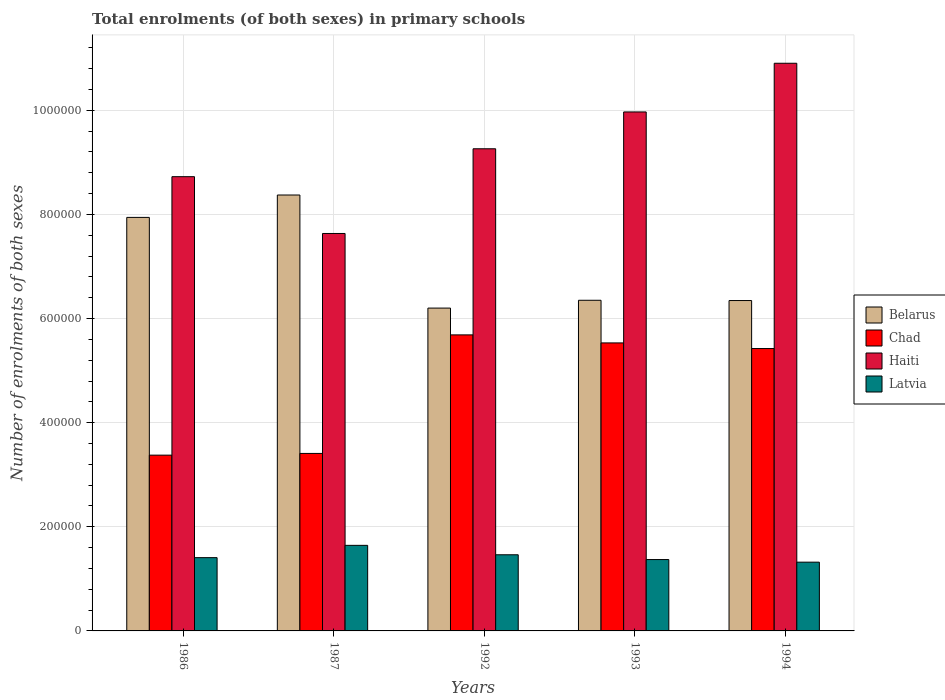How many different coloured bars are there?
Your answer should be compact. 4. Are the number of bars per tick equal to the number of legend labels?
Offer a terse response. Yes. Are the number of bars on each tick of the X-axis equal?
Keep it short and to the point. Yes. How many bars are there on the 4th tick from the left?
Keep it short and to the point. 4. What is the label of the 1st group of bars from the left?
Offer a very short reply. 1986. In how many cases, is the number of bars for a given year not equal to the number of legend labels?
Ensure brevity in your answer.  0. What is the number of enrolments in primary schools in Haiti in 1993?
Offer a terse response. 9.97e+05. Across all years, what is the maximum number of enrolments in primary schools in Latvia?
Provide a short and direct response. 1.64e+05. Across all years, what is the minimum number of enrolments in primary schools in Chad?
Provide a short and direct response. 3.38e+05. In which year was the number of enrolments in primary schools in Chad maximum?
Provide a short and direct response. 1992. In which year was the number of enrolments in primary schools in Latvia minimum?
Provide a short and direct response. 1994. What is the total number of enrolments in primary schools in Belarus in the graph?
Offer a very short reply. 3.52e+06. What is the difference between the number of enrolments in primary schools in Chad in 1992 and that in 1994?
Your answer should be very brief. 2.62e+04. What is the difference between the number of enrolments in primary schools in Haiti in 1993 and the number of enrolments in primary schools in Belarus in 1987?
Your response must be concise. 1.60e+05. What is the average number of enrolments in primary schools in Chad per year?
Keep it short and to the point. 4.69e+05. In the year 1987, what is the difference between the number of enrolments in primary schools in Latvia and number of enrolments in primary schools in Haiti?
Your answer should be very brief. -5.99e+05. In how many years, is the number of enrolments in primary schools in Belarus greater than 240000?
Keep it short and to the point. 5. What is the ratio of the number of enrolments in primary schools in Chad in 1986 to that in 1994?
Make the answer very short. 0.62. Is the difference between the number of enrolments in primary schools in Latvia in 1993 and 1994 greater than the difference between the number of enrolments in primary schools in Haiti in 1993 and 1994?
Keep it short and to the point. Yes. What is the difference between the highest and the second highest number of enrolments in primary schools in Chad?
Keep it short and to the point. 1.54e+04. What is the difference between the highest and the lowest number of enrolments in primary schools in Chad?
Make the answer very short. 2.31e+05. In how many years, is the number of enrolments in primary schools in Haiti greater than the average number of enrolments in primary schools in Haiti taken over all years?
Offer a very short reply. 2. Is the sum of the number of enrolments in primary schools in Chad in 1993 and 1994 greater than the maximum number of enrolments in primary schools in Haiti across all years?
Ensure brevity in your answer.  Yes. What does the 4th bar from the left in 1986 represents?
Your response must be concise. Latvia. What does the 2nd bar from the right in 1992 represents?
Keep it short and to the point. Haiti. Is it the case that in every year, the sum of the number of enrolments in primary schools in Chad and number of enrolments in primary schools in Latvia is greater than the number of enrolments in primary schools in Belarus?
Make the answer very short. No. Are all the bars in the graph horizontal?
Give a very brief answer. No. How many years are there in the graph?
Provide a short and direct response. 5. Are the values on the major ticks of Y-axis written in scientific E-notation?
Provide a succinct answer. No. Does the graph contain any zero values?
Provide a succinct answer. No. Does the graph contain grids?
Your response must be concise. Yes. How are the legend labels stacked?
Provide a succinct answer. Vertical. What is the title of the graph?
Offer a terse response. Total enrolments (of both sexes) in primary schools. Does "Jamaica" appear as one of the legend labels in the graph?
Offer a very short reply. No. What is the label or title of the X-axis?
Offer a terse response. Years. What is the label or title of the Y-axis?
Provide a succinct answer. Number of enrolments of both sexes. What is the Number of enrolments of both sexes of Belarus in 1986?
Make the answer very short. 7.94e+05. What is the Number of enrolments of both sexes in Chad in 1986?
Offer a terse response. 3.38e+05. What is the Number of enrolments of both sexes in Haiti in 1986?
Offer a terse response. 8.72e+05. What is the Number of enrolments of both sexes of Latvia in 1986?
Provide a short and direct response. 1.41e+05. What is the Number of enrolments of both sexes in Belarus in 1987?
Provide a short and direct response. 8.37e+05. What is the Number of enrolments of both sexes in Chad in 1987?
Your response must be concise. 3.41e+05. What is the Number of enrolments of both sexes in Haiti in 1987?
Give a very brief answer. 7.63e+05. What is the Number of enrolments of both sexes in Latvia in 1987?
Your answer should be compact. 1.64e+05. What is the Number of enrolments of both sexes of Belarus in 1992?
Offer a very short reply. 6.20e+05. What is the Number of enrolments of both sexes in Chad in 1992?
Offer a very short reply. 5.69e+05. What is the Number of enrolments of both sexes in Haiti in 1992?
Keep it short and to the point. 9.26e+05. What is the Number of enrolments of both sexes of Latvia in 1992?
Provide a succinct answer. 1.46e+05. What is the Number of enrolments of both sexes of Belarus in 1993?
Your answer should be compact. 6.35e+05. What is the Number of enrolments of both sexes in Chad in 1993?
Ensure brevity in your answer.  5.53e+05. What is the Number of enrolments of both sexes of Haiti in 1993?
Provide a succinct answer. 9.97e+05. What is the Number of enrolments of both sexes in Latvia in 1993?
Keep it short and to the point. 1.37e+05. What is the Number of enrolments of both sexes in Belarus in 1994?
Provide a succinct answer. 6.35e+05. What is the Number of enrolments of both sexes of Chad in 1994?
Your answer should be very brief. 5.42e+05. What is the Number of enrolments of both sexes in Haiti in 1994?
Give a very brief answer. 1.09e+06. What is the Number of enrolments of both sexes of Latvia in 1994?
Your answer should be very brief. 1.32e+05. Across all years, what is the maximum Number of enrolments of both sexes in Belarus?
Keep it short and to the point. 8.37e+05. Across all years, what is the maximum Number of enrolments of both sexes in Chad?
Provide a short and direct response. 5.69e+05. Across all years, what is the maximum Number of enrolments of both sexes of Haiti?
Make the answer very short. 1.09e+06. Across all years, what is the maximum Number of enrolments of both sexes of Latvia?
Ensure brevity in your answer.  1.64e+05. Across all years, what is the minimum Number of enrolments of both sexes of Belarus?
Ensure brevity in your answer.  6.20e+05. Across all years, what is the minimum Number of enrolments of both sexes of Chad?
Offer a very short reply. 3.38e+05. Across all years, what is the minimum Number of enrolments of both sexes of Haiti?
Your answer should be compact. 7.63e+05. Across all years, what is the minimum Number of enrolments of both sexes in Latvia?
Your response must be concise. 1.32e+05. What is the total Number of enrolments of both sexes of Belarus in the graph?
Your answer should be compact. 3.52e+06. What is the total Number of enrolments of both sexes of Chad in the graph?
Keep it short and to the point. 2.34e+06. What is the total Number of enrolments of both sexes of Haiti in the graph?
Provide a short and direct response. 4.65e+06. What is the total Number of enrolments of both sexes of Latvia in the graph?
Your answer should be compact. 7.21e+05. What is the difference between the Number of enrolments of both sexes in Belarus in 1986 and that in 1987?
Your response must be concise. -4.30e+04. What is the difference between the Number of enrolments of both sexes in Chad in 1986 and that in 1987?
Keep it short and to the point. -3304. What is the difference between the Number of enrolments of both sexes in Haiti in 1986 and that in 1987?
Give a very brief answer. 1.09e+05. What is the difference between the Number of enrolments of both sexes in Latvia in 1986 and that in 1987?
Make the answer very short. -2.36e+04. What is the difference between the Number of enrolments of both sexes of Belarus in 1986 and that in 1992?
Offer a terse response. 1.74e+05. What is the difference between the Number of enrolments of both sexes of Chad in 1986 and that in 1992?
Make the answer very short. -2.31e+05. What is the difference between the Number of enrolments of both sexes of Haiti in 1986 and that in 1992?
Offer a terse response. -5.36e+04. What is the difference between the Number of enrolments of both sexes in Latvia in 1986 and that in 1992?
Offer a terse response. -5506. What is the difference between the Number of enrolments of both sexes in Belarus in 1986 and that in 1993?
Your answer should be very brief. 1.59e+05. What is the difference between the Number of enrolments of both sexes of Chad in 1986 and that in 1993?
Provide a short and direct response. -2.16e+05. What is the difference between the Number of enrolments of both sexes in Haiti in 1986 and that in 1993?
Your answer should be very brief. -1.24e+05. What is the difference between the Number of enrolments of both sexes of Latvia in 1986 and that in 1993?
Offer a terse response. 3649. What is the difference between the Number of enrolments of both sexes of Belarus in 1986 and that in 1994?
Ensure brevity in your answer.  1.60e+05. What is the difference between the Number of enrolments of both sexes in Chad in 1986 and that in 1994?
Keep it short and to the point. -2.05e+05. What is the difference between the Number of enrolments of both sexes in Haiti in 1986 and that in 1994?
Make the answer very short. -2.18e+05. What is the difference between the Number of enrolments of both sexes of Latvia in 1986 and that in 1994?
Your answer should be compact. 8685. What is the difference between the Number of enrolments of both sexes of Belarus in 1987 and that in 1992?
Your response must be concise. 2.17e+05. What is the difference between the Number of enrolments of both sexes of Chad in 1987 and that in 1992?
Your response must be concise. -2.28e+05. What is the difference between the Number of enrolments of both sexes in Haiti in 1987 and that in 1992?
Your response must be concise. -1.63e+05. What is the difference between the Number of enrolments of both sexes of Latvia in 1987 and that in 1992?
Provide a succinct answer. 1.81e+04. What is the difference between the Number of enrolments of both sexes in Belarus in 1987 and that in 1993?
Your answer should be compact. 2.02e+05. What is the difference between the Number of enrolments of both sexes in Chad in 1987 and that in 1993?
Keep it short and to the point. -2.12e+05. What is the difference between the Number of enrolments of both sexes in Haiti in 1987 and that in 1993?
Your answer should be very brief. -2.33e+05. What is the difference between the Number of enrolments of both sexes in Latvia in 1987 and that in 1993?
Your response must be concise. 2.73e+04. What is the difference between the Number of enrolments of both sexes of Belarus in 1987 and that in 1994?
Make the answer very short. 2.03e+05. What is the difference between the Number of enrolments of both sexes in Chad in 1987 and that in 1994?
Your response must be concise. -2.01e+05. What is the difference between the Number of enrolments of both sexes in Haiti in 1987 and that in 1994?
Provide a succinct answer. -3.27e+05. What is the difference between the Number of enrolments of both sexes of Latvia in 1987 and that in 1994?
Offer a terse response. 3.23e+04. What is the difference between the Number of enrolments of both sexes in Belarus in 1992 and that in 1993?
Provide a short and direct response. -1.50e+04. What is the difference between the Number of enrolments of both sexes in Chad in 1992 and that in 1993?
Give a very brief answer. 1.54e+04. What is the difference between the Number of enrolments of both sexes in Haiti in 1992 and that in 1993?
Your answer should be compact. -7.08e+04. What is the difference between the Number of enrolments of both sexes of Latvia in 1992 and that in 1993?
Make the answer very short. 9155. What is the difference between the Number of enrolments of both sexes of Belarus in 1992 and that in 1994?
Your response must be concise. -1.45e+04. What is the difference between the Number of enrolments of both sexes of Chad in 1992 and that in 1994?
Offer a very short reply. 2.62e+04. What is the difference between the Number of enrolments of both sexes in Haiti in 1992 and that in 1994?
Your answer should be very brief. -1.64e+05. What is the difference between the Number of enrolments of both sexes in Latvia in 1992 and that in 1994?
Offer a very short reply. 1.42e+04. What is the difference between the Number of enrolments of both sexes of Belarus in 1993 and that in 1994?
Offer a very short reply. 500. What is the difference between the Number of enrolments of both sexes of Chad in 1993 and that in 1994?
Your answer should be compact. 1.08e+04. What is the difference between the Number of enrolments of both sexes of Haiti in 1993 and that in 1994?
Offer a very short reply. -9.35e+04. What is the difference between the Number of enrolments of both sexes of Latvia in 1993 and that in 1994?
Your answer should be compact. 5036. What is the difference between the Number of enrolments of both sexes of Belarus in 1986 and the Number of enrolments of both sexes of Chad in 1987?
Give a very brief answer. 4.53e+05. What is the difference between the Number of enrolments of both sexes in Belarus in 1986 and the Number of enrolments of both sexes in Haiti in 1987?
Provide a short and direct response. 3.09e+04. What is the difference between the Number of enrolments of both sexes in Belarus in 1986 and the Number of enrolments of both sexes in Latvia in 1987?
Offer a terse response. 6.30e+05. What is the difference between the Number of enrolments of both sexes of Chad in 1986 and the Number of enrolments of both sexes of Haiti in 1987?
Make the answer very short. -4.26e+05. What is the difference between the Number of enrolments of both sexes in Chad in 1986 and the Number of enrolments of both sexes in Latvia in 1987?
Make the answer very short. 1.73e+05. What is the difference between the Number of enrolments of both sexes in Haiti in 1986 and the Number of enrolments of both sexes in Latvia in 1987?
Make the answer very short. 7.08e+05. What is the difference between the Number of enrolments of both sexes of Belarus in 1986 and the Number of enrolments of both sexes of Chad in 1992?
Your response must be concise. 2.26e+05. What is the difference between the Number of enrolments of both sexes of Belarus in 1986 and the Number of enrolments of both sexes of Haiti in 1992?
Provide a succinct answer. -1.32e+05. What is the difference between the Number of enrolments of both sexes in Belarus in 1986 and the Number of enrolments of both sexes in Latvia in 1992?
Provide a short and direct response. 6.48e+05. What is the difference between the Number of enrolments of both sexes of Chad in 1986 and the Number of enrolments of both sexes of Haiti in 1992?
Make the answer very short. -5.88e+05. What is the difference between the Number of enrolments of both sexes of Chad in 1986 and the Number of enrolments of both sexes of Latvia in 1992?
Keep it short and to the point. 1.91e+05. What is the difference between the Number of enrolments of both sexes of Haiti in 1986 and the Number of enrolments of both sexes of Latvia in 1992?
Keep it short and to the point. 7.26e+05. What is the difference between the Number of enrolments of both sexes of Belarus in 1986 and the Number of enrolments of both sexes of Chad in 1993?
Ensure brevity in your answer.  2.41e+05. What is the difference between the Number of enrolments of both sexes in Belarus in 1986 and the Number of enrolments of both sexes in Haiti in 1993?
Your response must be concise. -2.03e+05. What is the difference between the Number of enrolments of both sexes of Belarus in 1986 and the Number of enrolments of both sexes of Latvia in 1993?
Offer a very short reply. 6.57e+05. What is the difference between the Number of enrolments of both sexes in Chad in 1986 and the Number of enrolments of both sexes in Haiti in 1993?
Your answer should be very brief. -6.59e+05. What is the difference between the Number of enrolments of both sexes in Chad in 1986 and the Number of enrolments of both sexes in Latvia in 1993?
Provide a short and direct response. 2.01e+05. What is the difference between the Number of enrolments of both sexes of Haiti in 1986 and the Number of enrolments of both sexes of Latvia in 1993?
Provide a succinct answer. 7.35e+05. What is the difference between the Number of enrolments of both sexes of Belarus in 1986 and the Number of enrolments of both sexes of Chad in 1994?
Your response must be concise. 2.52e+05. What is the difference between the Number of enrolments of both sexes in Belarus in 1986 and the Number of enrolments of both sexes in Haiti in 1994?
Provide a short and direct response. -2.96e+05. What is the difference between the Number of enrolments of both sexes of Belarus in 1986 and the Number of enrolments of both sexes of Latvia in 1994?
Ensure brevity in your answer.  6.62e+05. What is the difference between the Number of enrolments of both sexes of Chad in 1986 and the Number of enrolments of both sexes of Haiti in 1994?
Make the answer very short. -7.53e+05. What is the difference between the Number of enrolments of both sexes of Chad in 1986 and the Number of enrolments of both sexes of Latvia in 1994?
Make the answer very short. 2.06e+05. What is the difference between the Number of enrolments of both sexes in Haiti in 1986 and the Number of enrolments of both sexes in Latvia in 1994?
Your answer should be very brief. 7.40e+05. What is the difference between the Number of enrolments of both sexes in Belarus in 1987 and the Number of enrolments of both sexes in Chad in 1992?
Make the answer very short. 2.69e+05. What is the difference between the Number of enrolments of both sexes in Belarus in 1987 and the Number of enrolments of both sexes in Haiti in 1992?
Provide a succinct answer. -8.88e+04. What is the difference between the Number of enrolments of both sexes in Belarus in 1987 and the Number of enrolments of both sexes in Latvia in 1992?
Your response must be concise. 6.91e+05. What is the difference between the Number of enrolments of both sexes in Chad in 1987 and the Number of enrolments of both sexes in Haiti in 1992?
Give a very brief answer. -5.85e+05. What is the difference between the Number of enrolments of both sexes of Chad in 1987 and the Number of enrolments of both sexes of Latvia in 1992?
Provide a short and direct response. 1.95e+05. What is the difference between the Number of enrolments of both sexes of Haiti in 1987 and the Number of enrolments of both sexes of Latvia in 1992?
Your answer should be very brief. 6.17e+05. What is the difference between the Number of enrolments of both sexes in Belarus in 1987 and the Number of enrolments of both sexes in Chad in 1993?
Provide a succinct answer. 2.84e+05. What is the difference between the Number of enrolments of both sexes in Belarus in 1987 and the Number of enrolments of both sexes in Haiti in 1993?
Provide a succinct answer. -1.60e+05. What is the difference between the Number of enrolments of both sexes of Belarus in 1987 and the Number of enrolments of both sexes of Latvia in 1993?
Ensure brevity in your answer.  7.00e+05. What is the difference between the Number of enrolments of both sexes of Chad in 1987 and the Number of enrolments of both sexes of Haiti in 1993?
Provide a short and direct response. -6.56e+05. What is the difference between the Number of enrolments of both sexes of Chad in 1987 and the Number of enrolments of both sexes of Latvia in 1993?
Make the answer very short. 2.04e+05. What is the difference between the Number of enrolments of both sexes of Haiti in 1987 and the Number of enrolments of both sexes of Latvia in 1993?
Ensure brevity in your answer.  6.26e+05. What is the difference between the Number of enrolments of both sexes in Belarus in 1987 and the Number of enrolments of both sexes in Chad in 1994?
Ensure brevity in your answer.  2.95e+05. What is the difference between the Number of enrolments of both sexes of Belarus in 1987 and the Number of enrolments of both sexes of Haiti in 1994?
Provide a short and direct response. -2.53e+05. What is the difference between the Number of enrolments of both sexes in Belarus in 1987 and the Number of enrolments of both sexes in Latvia in 1994?
Offer a very short reply. 7.05e+05. What is the difference between the Number of enrolments of both sexes of Chad in 1987 and the Number of enrolments of both sexes of Haiti in 1994?
Provide a succinct answer. -7.49e+05. What is the difference between the Number of enrolments of both sexes in Chad in 1987 and the Number of enrolments of both sexes in Latvia in 1994?
Offer a very short reply. 2.09e+05. What is the difference between the Number of enrolments of both sexes in Haiti in 1987 and the Number of enrolments of both sexes in Latvia in 1994?
Your answer should be compact. 6.31e+05. What is the difference between the Number of enrolments of both sexes of Belarus in 1992 and the Number of enrolments of both sexes of Chad in 1993?
Provide a succinct answer. 6.69e+04. What is the difference between the Number of enrolments of both sexes in Belarus in 1992 and the Number of enrolments of both sexes in Haiti in 1993?
Offer a very short reply. -3.77e+05. What is the difference between the Number of enrolments of both sexes of Belarus in 1992 and the Number of enrolments of both sexes of Latvia in 1993?
Offer a terse response. 4.83e+05. What is the difference between the Number of enrolments of both sexes in Chad in 1992 and the Number of enrolments of both sexes in Haiti in 1993?
Your response must be concise. -4.28e+05. What is the difference between the Number of enrolments of both sexes in Chad in 1992 and the Number of enrolments of both sexes in Latvia in 1993?
Provide a succinct answer. 4.32e+05. What is the difference between the Number of enrolments of both sexes in Haiti in 1992 and the Number of enrolments of both sexes in Latvia in 1993?
Offer a terse response. 7.89e+05. What is the difference between the Number of enrolments of both sexes in Belarus in 1992 and the Number of enrolments of both sexes in Chad in 1994?
Provide a short and direct response. 7.77e+04. What is the difference between the Number of enrolments of both sexes in Belarus in 1992 and the Number of enrolments of both sexes in Haiti in 1994?
Your answer should be compact. -4.70e+05. What is the difference between the Number of enrolments of both sexes in Belarus in 1992 and the Number of enrolments of both sexes in Latvia in 1994?
Offer a very short reply. 4.88e+05. What is the difference between the Number of enrolments of both sexes in Chad in 1992 and the Number of enrolments of both sexes in Haiti in 1994?
Provide a succinct answer. -5.22e+05. What is the difference between the Number of enrolments of both sexes of Chad in 1992 and the Number of enrolments of both sexes of Latvia in 1994?
Your response must be concise. 4.37e+05. What is the difference between the Number of enrolments of both sexes in Haiti in 1992 and the Number of enrolments of both sexes in Latvia in 1994?
Offer a very short reply. 7.94e+05. What is the difference between the Number of enrolments of both sexes in Belarus in 1993 and the Number of enrolments of both sexes in Chad in 1994?
Offer a very short reply. 9.27e+04. What is the difference between the Number of enrolments of both sexes in Belarus in 1993 and the Number of enrolments of both sexes in Haiti in 1994?
Your answer should be very brief. -4.55e+05. What is the difference between the Number of enrolments of both sexes of Belarus in 1993 and the Number of enrolments of both sexes of Latvia in 1994?
Provide a short and direct response. 5.03e+05. What is the difference between the Number of enrolments of both sexes of Chad in 1993 and the Number of enrolments of both sexes of Haiti in 1994?
Make the answer very short. -5.37e+05. What is the difference between the Number of enrolments of both sexes of Chad in 1993 and the Number of enrolments of both sexes of Latvia in 1994?
Give a very brief answer. 4.21e+05. What is the difference between the Number of enrolments of both sexes in Haiti in 1993 and the Number of enrolments of both sexes in Latvia in 1994?
Your answer should be compact. 8.65e+05. What is the average Number of enrolments of both sexes of Belarus per year?
Keep it short and to the point. 7.04e+05. What is the average Number of enrolments of both sexes in Chad per year?
Your response must be concise. 4.69e+05. What is the average Number of enrolments of both sexes in Haiti per year?
Offer a terse response. 9.30e+05. What is the average Number of enrolments of both sexes of Latvia per year?
Your answer should be very brief. 1.44e+05. In the year 1986, what is the difference between the Number of enrolments of both sexes of Belarus and Number of enrolments of both sexes of Chad?
Make the answer very short. 4.57e+05. In the year 1986, what is the difference between the Number of enrolments of both sexes in Belarus and Number of enrolments of both sexes in Haiti?
Give a very brief answer. -7.82e+04. In the year 1986, what is the difference between the Number of enrolments of both sexes of Belarus and Number of enrolments of both sexes of Latvia?
Ensure brevity in your answer.  6.54e+05. In the year 1986, what is the difference between the Number of enrolments of both sexes of Chad and Number of enrolments of both sexes of Haiti?
Provide a short and direct response. -5.35e+05. In the year 1986, what is the difference between the Number of enrolments of both sexes of Chad and Number of enrolments of both sexes of Latvia?
Offer a terse response. 1.97e+05. In the year 1986, what is the difference between the Number of enrolments of both sexes of Haiti and Number of enrolments of both sexes of Latvia?
Provide a succinct answer. 7.32e+05. In the year 1987, what is the difference between the Number of enrolments of both sexes in Belarus and Number of enrolments of both sexes in Chad?
Your response must be concise. 4.96e+05. In the year 1987, what is the difference between the Number of enrolments of both sexes in Belarus and Number of enrolments of both sexes in Haiti?
Your response must be concise. 7.39e+04. In the year 1987, what is the difference between the Number of enrolments of both sexes of Belarus and Number of enrolments of both sexes of Latvia?
Your answer should be very brief. 6.73e+05. In the year 1987, what is the difference between the Number of enrolments of both sexes in Chad and Number of enrolments of both sexes in Haiti?
Offer a terse response. -4.22e+05. In the year 1987, what is the difference between the Number of enrolments of both sexes of Chad and Number of enrolments of both sexes of Latvia?
Your answer should be compact. 1.77e+05. In the year 1987, what is the difference between the Number of enrolments of both sexes in Haiti and Number of enrolments of both sexes in Latvia?
Your answer should be very brief. 5.99e+05. In the year 1992, what is the difference between the Number of enrolments of both sexes in Belarus and Number of enrolments of both sexes in Chad?
Your response must be concise. 5.15e+04. In the year 1992, what is the difference between the Number of enrolments of both sexes of Belarus and Number of enrolments of both sexes of Haiti?
Offer a terse response. -3.06e+05. In the year 1992, what is the difference between the Number of enrolments of both sexes of Belarus and Number of enrolments of both sexes of Latvia?
Make the answer very short. 4.74e+05. In the year 1992, what is the difference between the Number of enrolments of both sexes in Chad and Number of enrolments of both sexes in Haiti?
Your answer should be compact. -3.57e+05. In the year 1992, what is the difference between the Number of enrolments of both sexes of Chad and Number of enrolments of both sexes of Latvia?
Your answer should be very brief. 4.22e+05. In the year 1992, what is the difference between the Number of enrolments of both sexes in Haiti and Number of enrolments of both sexes in Latvia?
Your answer should be very brief. 7.80e+05. In the year 1993, what is the difference between the Number of enrolments of both sexes of Belarus and Number of enrolments of both sexes of Chad?
Make the answer very short. 8.19e+04. In the year 1993, what is the difference between the Number of enrolments of both sexes of Belarus and Number of enrolments of both sexes of Haiti?
Offer a very short reply. -3.62e+05. In the year 1993, what is the difference between the Number of enrolments of both sexes in Belarus and Number of enrolments of both sexes in Latvia?
Keep it short and to the point. 4.98e+05. In the year 1993, what is the difference between the Number of enrolments of both sexes of Chad and Number of enrolments of both sexes of Haiti?
Provide a succinct answer. -4.44e+05. In the year 1993, what is the difference between the Number of enrolments of both sexes of Chad and Number of enrolments of both sexes of Latvia?
Provide a short and direct response. 4.16e+05. In the year 1993, what is the difference between the Number of enrolments of both sexes in Haiti and Number of enrolments of both sexes in Latvia?
Provide a short and direct response. 8.60e+05. In the year 1994, what is the difference between the Number of enrolments of both sexes in Belarus and Number of enrolments of both sexes in Chad?
Offer a terse response. 9.22e+04. In the year 1994, what is the difference between the Number of enrolments of both sexes of Belarus and Number of enrolments of both sexes of Haiti?
Your response must be concise. -4.56e+05. In the year 1994, what is the difference between the Number of enrolments of both sexes in Belarus and Number of enrolments of both sexes in Latvia?
Offer a terse response. 5.03e+05. In the year 1994, what is the difference between the Number of enrolments of both sexes of Chad and Number of enrolments of both sexes of Haiti?
Offer a terse response. -5.48e+05. In the year 1994, what is the difference between the Number of enrolments of both sexes of Chad and Number of enrolments of both sexes of Latvia?
Give a very brief answer. 4.10e+05. In the year 1994, what is the difference between the Number of enrolments of both sexes in Haiti and Number of enrolments of both sexes in Latvia?
Offer a terse response. 9.58e+05. What is the ratio of the Number of enrolments of both sexes of Belarus in 1986 to that in 1987?
Your answer should be compact. 0.95. What is the ratio of the Number of enrolments of both sexes of Chad in 1986 to that in 1987?
Make the answer very short. 0.99. What is the ratio of the Number of enrolments of both sexes of Latvia in 1986 to that in 1987?
Provide a succinct answer. 0.86. What is the ratio of the Number of enrolments of both sexes of Belarus in 1986 to that in 1992?
Your response must be concise. 1.28. What is the ratio of the Number of enrolments of both sexes in Chad in 1986 to that in 1992?
Offer a very short reply. 0.59. What is the ratio of the Number of enrolments of both sexes of Haiti in 1986 to that in 1992?
Your response must be concise. 0.94. What is the ratio of the Number of enrolments of both sexes in Latvia in 1986 to that in 1992?
Offer a terse response. 0.96. What is the ratio of the Number of enrolments of both sexes in Belarus in 1986 to that in 1993?
Your answer should be very brief. 1.25. What is the ratio of the Number of enrolments of both sexes in Chad in 1986 to that in 1993?
Provide a short and direct response. 0.61. What is the ratio of the Number of enrolments of both sexes of Haiti in 1986 to that in 1993?
Ensure brevity in your answer.  0.88. What is the ratio of the Number of enrolments of both sexes in Latvia in 1986 to that in 1993?
Your answer should be compact. 1.03. What is the ratio of the Number of enrolments of both sexes in Belarus in 1986 to that in 1994?
Give a very brief answer. 1.25. What is the ratio of the Number of enrolments of both sexes of Chad in 1986 to that in 1994?
Your response must be concise. 0.62. What is the ratio of the Number of enrolments of both sexes of Haiti in 1986 to that in 1994?
Provide a succinct answer. 0.8. What is the ratio of the Number of enrolments of both sexes in Latvia in 1986 to that in 1994?
Keep it short and to the point. 1.07. What is the ratio of the Number of enrolments of both sexes of Belarus in 1987 to that in 1992?
Give a very brief answer. 1.35. What is the ratio of the Number of enrolments of both sexes of Chad in 1987 to that in 1992?
Your response must be concise. 0.6. What is the ratio of the Number of enrolments of both sexes in Haiti in 1987 to that in 1992?
Your answer should be compact. 0.82. What is the ratio of the Number of enrolments of both sexes of Latvia in 1987 to that in 1992?
Provide a short and direct response. 1.12. What is the ratio of the Number of enrolments of both sexes in Belarus in 1987 to that in 1993?
Make the answer very short. 1.32. What is the ratio of the Number of enrolments of both sexes of Chad in 1987 to that in 1993?
Offer a very short reply. 0.62. What is the ratio of the Number of enrolments of both sexes of Haiti in 1987 to that in 1993?
Give a very brief answer. 0.77. What is the ratio of the Number of enrolments of both sexes of Latvia in 1987 to that in 1993?
Offer a very short reply. 1.2. What is the ratio of the Number of enrolments of both sexes in Belarus in 1987 to that in 1994?
Your answer should be compact. 1.32. What is the ratio of the Number of enrolments of both sexes in Chad in 1987 to that in 1994?
Give a very brief answer. 0.63. What is the ratio of the Number of enrolments of both sexes of Haiti in 1987 to that in 1994?
Offer a terse response. 0.7. What is the ratio of the Number of enrolments of both sexes of Latvia in 1987 to that in 1994?
Offer a terse response. 1.24. What is the ratio of the Number of enrolments of both sexes in Belarus in 1992 to that in 1993?
Offer a terse response. 0.98. What is the ratio of the Number of enrolments of both sexes of Chad in 1992 to that in 1993?
Make the answer very short. 1.03. What is the ratio of the Number of enrolments of both sexes in Haiti in 1992 to that in 1993?
Your answer should be compact. 0.93. What is the ratio of the Number of enrolments of both sexes of Latvia in 1992 to that in 1993?
Offer a very short reply. 1.07. What is the ratio of the Number of enrolments of both sexes in Belarus in 1992 to that in 1994?
Give a very brief answer. 0.98. What is the ratio of the Number of enrolments of both sexes of Chad in 1992 to that in 1994?
Keep it short and to the point. 1.05. What is the ratio of the Number of enrolments of both sexes in Haiti in 1992 to that in 1994?
Ensure brevity in your answer.  0.85. What is the ratio of the Number of enrolments of both sexes of Latvia in 1992 to that in 1994?
Your answer should be compact. 1.11. What is the ratio of the Number of enrolments of both sexes in Chad in 1993 to that in 1994?
Keep it short and to the point. 1.02. What is the ratio of the Number of enrolments of both sexes of Haiti in 1993 to that in 1994?
Your response must be concise. 0.91. What is the ratio of the Number of enrolments of both sexes of Latvia in 1993 to that in 1994?
Your answer should be very brief. 1.04. What is the difference between the highest and the second highest Number of enrolments of both sexes of Belarus?
Provide a short and direct response. 4.30e+04. What is the difference between the highest and the second highest Number of enrolments of both sexes in Chad?
Provide a short and direct response. 1.54e+04. What is the difference between the highest and the second highest Number of enrolments of both sexes of Haiti?
Give a very brief answer. 9.35e+04. What is the difference between the highest and the second highest Number of enrolments of both sexes of Latvia?
Provide a succinct answer. 1.81e+04. What is the difference between the highest and the lowest Number of enrolments of both sexes in Belarus?
Your answer should be very brief. 2.17e+05. What is the difference between the highest and the lowest Number of enrolments of both sexes in Chad?
Provide a short and direct response. 2.31e+05. What is the difference between the highest and the lowest Number of enrolments of both sexes of Haiti?
Provide a succinct answer. 3.27e+05. What is the difference between the highest and the lowest Number of enrolments of both sexes of Latvia?
Offer a very short reply. 3.23e+04. 